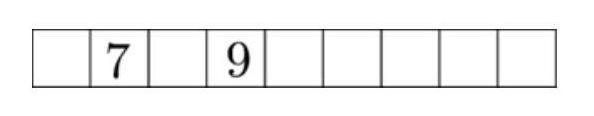What initial steps should be considered when attempting to solve this number placement puzzle? To start solving this puzzle, you should consider placing the numbers adjacent to the fixed numbers 7 and 9 such that the sum of these three numbers respects the puzzle's rules. Experimenting with possible numbers in these adjacent squares will provide a foundation to proceed and solve for the subsequent squares. 